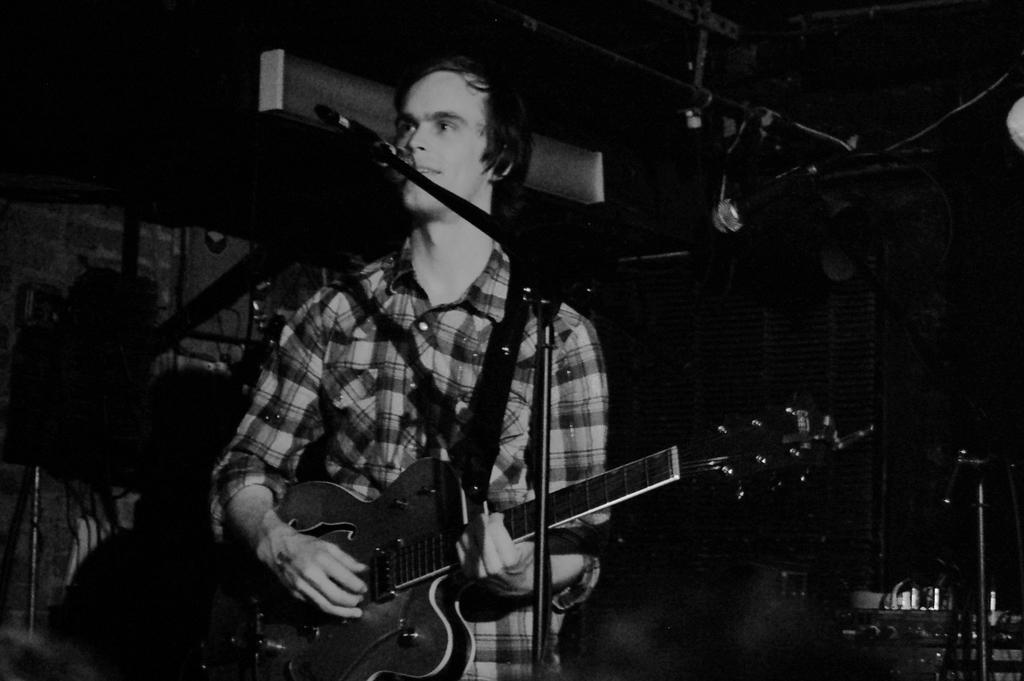What is the main subject of the image? The main subject of the image is a man. What is the man doing in the image? The man is standing and holding a guitar. What object is present near the man? There is a microphone in the image. What can be seen in the background of the image? There are musical instruments in the background of the image, and the background is dark. How many snails can be seen crawling on the guitar in the image? There are no snails present in the image, so it is not possible to determine how many would be crawling on the guitar. 